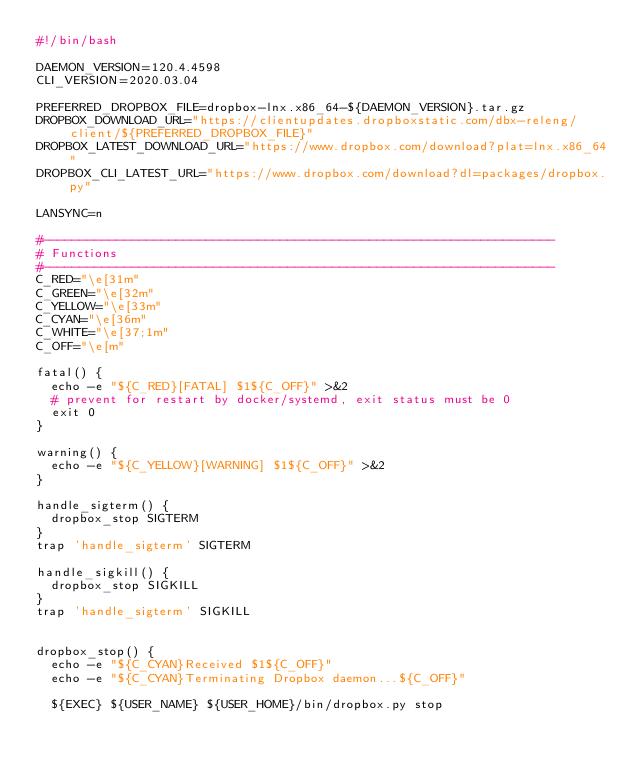Convert code to text. <code><loc_0><loc_0><loc_500><loc_500><_Bash_>#!/bin/bash

DAEMON_VERSION=120.4.4598
CLI_VERSION=2020.03.04

PREFERRED_DROPBOX_FILE=dropbox-lnx.x86_64-${DAEMON_VERSION}.tar.gz
DROPBOX_DOWNLOAD_URL="https://clientupdates.dropboxstatic.com/dbx-releng/client/${PREFERRED_DROPBOX_FILE}"
DROPBOX_LATEST_DOWNLOAD_URL="https://www.dropbox.com/download?plat=lnx.x86_64"
DROPBOX_CLI_LATEST_URL="https://www.dropbox.com/download?dl=packages/dropbox.py"

LANSYNC=n

#---------------------------------------------------------------------
# Functions
#---------------------------------------------------------------------
C_RED="\e[31m"
C_GREEN="\e[32m"
C_YELLOW="\e[33m"
C_CYAN="\e[36m"
C_WHITE="\e[37;1m"
C_OFF="\e[m"

fatal() {
  echo -e "${C_RED}[FATAL] $1${C_OFF}" >&2
  # prevent for restart by docker/systemd, exit status must be 0
  exit 0
}

warning() {
  echo -e "${C_YELLOW}[WARNING] $1${C_OFF}" >&2
}

handle_sigterm() {
  dropbox_stop SIGTERM
}
trap 'handle_sigterm' SIGTERM

handle_sigkill() {
  dropbox_stop SIGKILL
}
trap 'handle_sigterm' SIGKILL


dropbox_stop() {
  echo -e "${C_CYAN}Received $1${C_OFF}"
  echo -e "${C_CYAN}Terminating Dropbox daemon...${C_OFF}"

  ${EXEC} ${USER_NAME} ${USER_HOME}/bin/dropbox.py stop</code> 